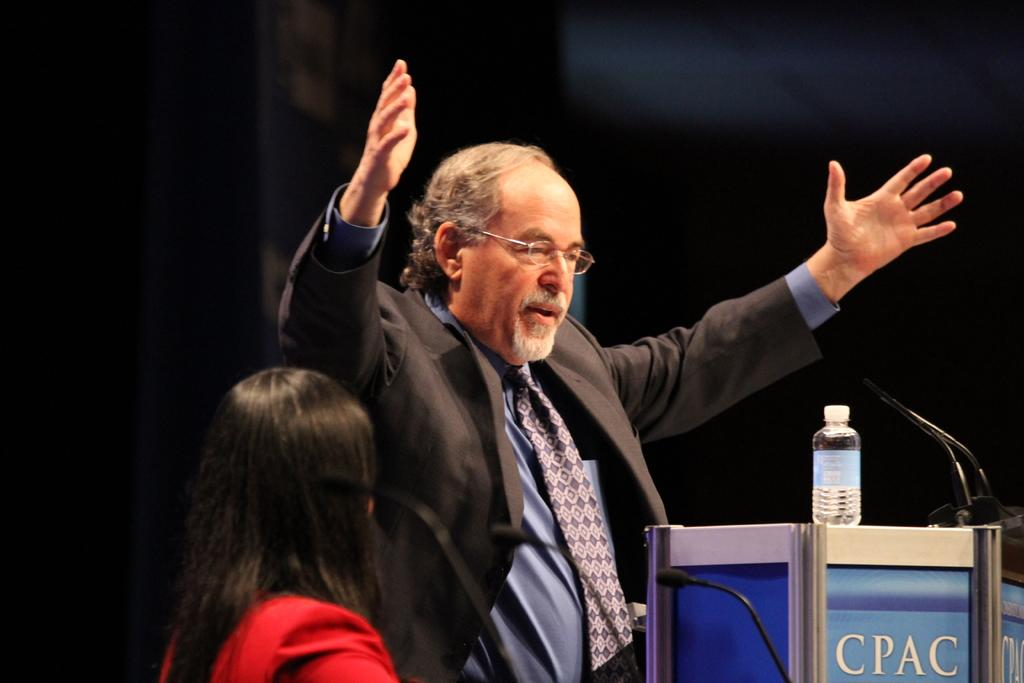Provide a one-sentence caption for the provided image. Man speaking in front of a podium that says "CPAC". 